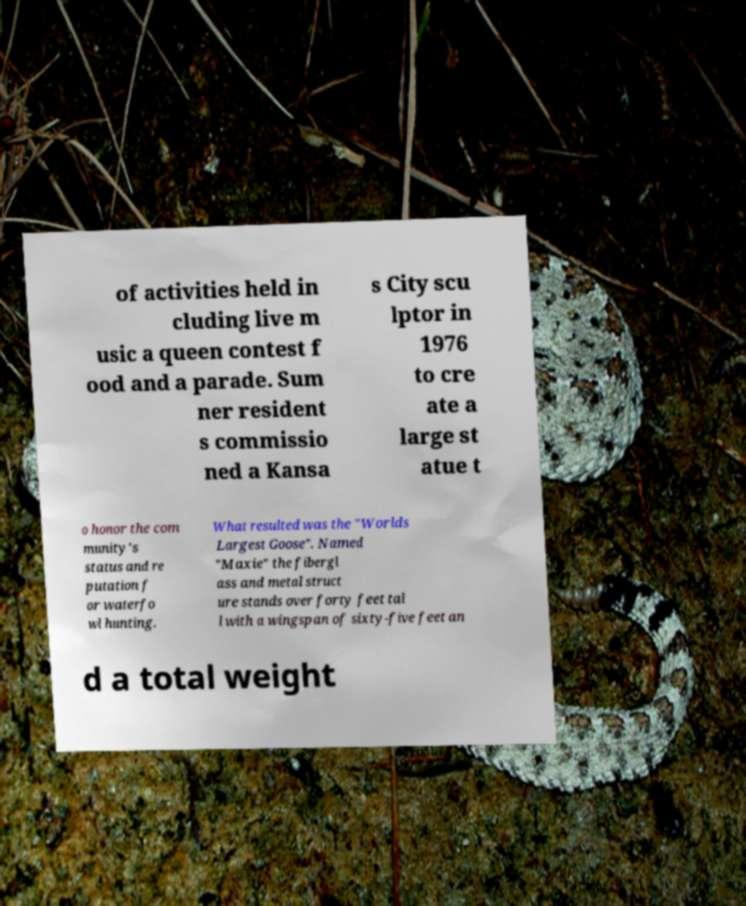For documentation purposes, I need the text within this image transcribed. Could you provide that? of activities held in cluding live m usic a queen contest f ood and a parade. Sum ner resident s commissio ned a Kansa s City scu lptor in 1976 to cre ate a large st atue t o honor the com munity's status and re putation f or waterfo wl hunting. What resulted was the "Worlds Largest Goose". Named "Maxie" the fibergl ass and metal struct ure stands over forty feet tal l with a wingspan of sixty-five feet an d a total weight 